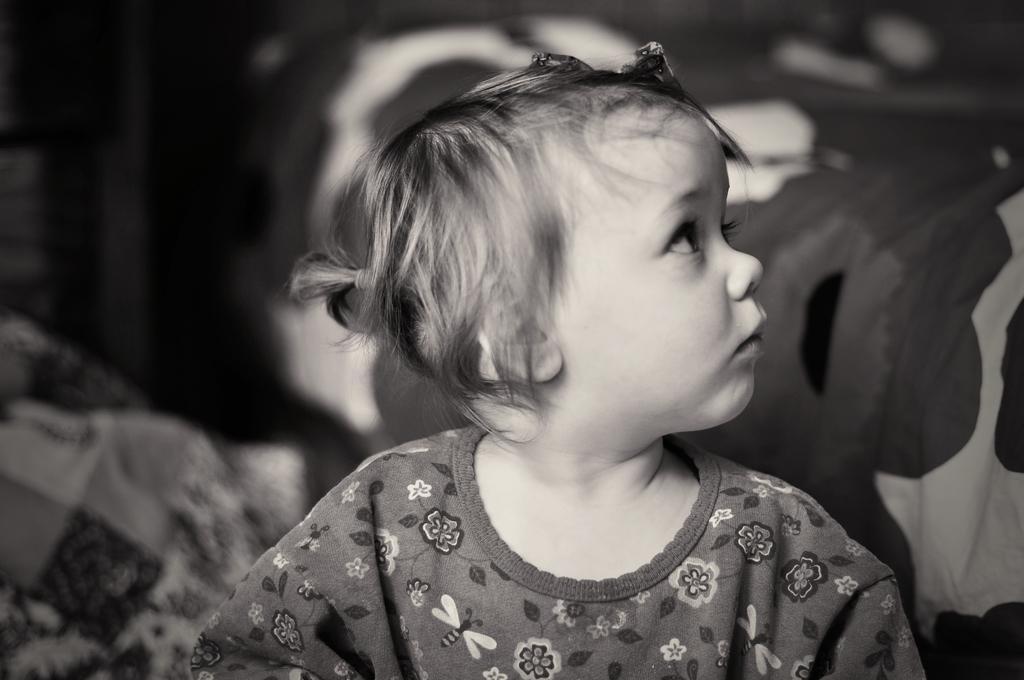Please provide a concise description of this image. This is a black and white image. In this image, we can see a small girl. On the right side of the image, there is a bed sheet. In the background, there is a blur view. 